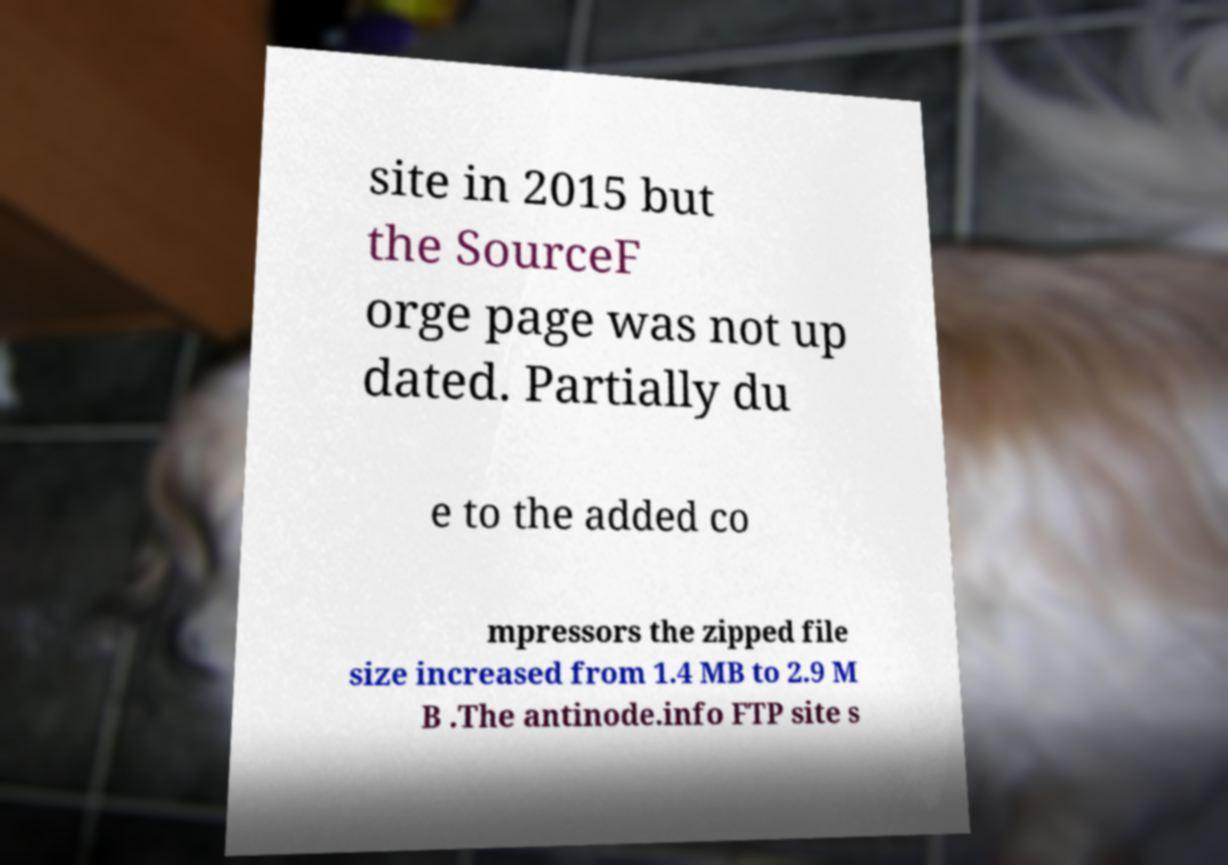What messages or text are displayed in this image? I need them in a readable, typed format. site in 2015 but the SourceF orge page was not up dated. Partially du e to the added co mpressors the zipped file size increased from 1.4 MB to 2.9 M B .The antinode.info FTP site s 